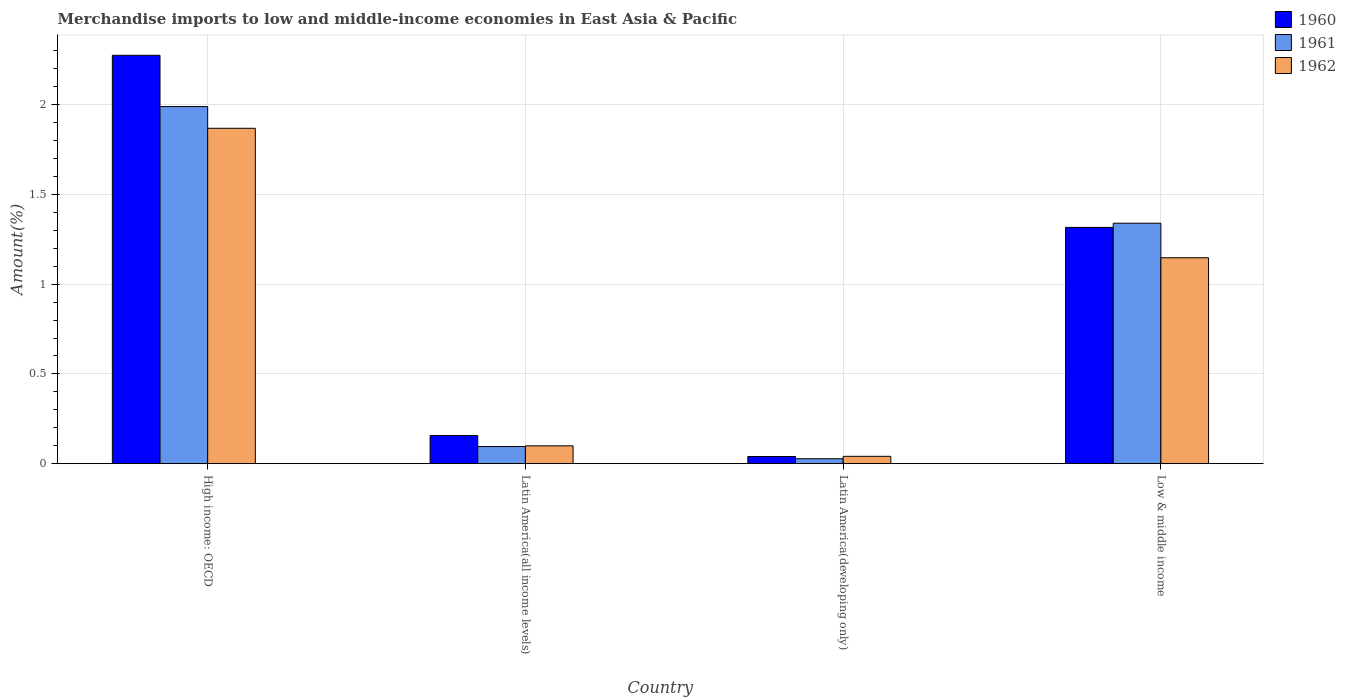Are the number of bars per tick equal to the number of legend labels?
Give a very brief answer. Yes. How many bars are there on the 4th tick from the left?
Your answer should be compact. 3. What is the label of the 3rd group of bars from the left?
Provide a succinct answer. Latin America(developing only). In how many cases, is the number of bars for a given country not equal to the number of legend labels?
Make the answer very short. 0. What is the percentage of amount earned from merchandise imports in 1960 in Low & middle income?
Make the answer very short. 1.32. Across all countries, what is the maximum percentage of amount earned from merchandise imports in 1961?
Provide a short and direct response. 1.99. Across all countries, what is the minimum percentage of amount earned from merchandise imports in 1962?
Provide a short and direct response. 0.04. In which country was the percentage of amount earned from merchandise imports in 1962 maximum?
Your answer should be very brief. High income: OECD. In which country was the percentage of amount earned from merchandise imports in 1961 minimum?
Provide a succinct answer. Latin America(developing only). What is the total percentage of amount earned from merchandise imports in 1961 in the graph?
Provide a short and direct response. 3.45. What is the difference between the percentage of amount earned from merchandise imports in 1962 in High income: OECD and that in Low & middle income?
Your response must be concise. 0.72. What is the difference between the percentage of amount earned from merchandise imports in 1960 in Latin America(developing only) and the percentage of amount earned from merchandise imports in 1961 in High income: OECD?
Keep it short and to the point. -1.95. What is the average percentage of amount earned from merchandise imports in 1961 per country?
Ensure brevity in your answer.  0.86. What is the difference between the percentage of amount earned from merchandise imports of/in 1961 and percentage of amount earned from merchandise imports of/in 1962 in Low & middle income?
Your response must be concise. 0.19. In how many countries, is the percentage of amount earned from merchandise imports in 1960 greater than 1.2 %?
Your answer should be very brief. 2. What is the ratio of the percentage of amount earned from merchandise imports in 1962 in Latin America(developing only) to that in Low & middle income?
Give a very brief answer. 0.04. Is the percentage of amount earned from merchandise imports in 1961 in High income: OECD less than that in Low & middle income?
Provide a short and direct response. No. Is the difference between the percentage of amount earned from merchandise imports in 1961 in Latin America(all income levels) and Low & middle income greater than the difference between the percentage of amount earned from merchandise imports in 1962 in Latin America(all income levels) and Low & middle income?
Provide a succinct answer. No. What is the difference between the highest and the second highest percentage of amount earned from merchandise imports in 1961?
Your response must be concise. -1.89. What is the difference between the highest and the lowest percentage of amount earned from merchandise imports in 1961?
Make the answer very short. 1.96. In how many countries, is the percentage of amount earned from merchandise imports in 1962 greater than the average percentage of amount earned from merchandise imports in 1962 taken over all countries?
Provide a succinct answer. 2. Is the sum of the percentage of amount earned from merchandise imports in 1961 in Latin America(developing only) and Low & middle income greater than the maximum percentage of amount earned from merchandise imports in 1962 across all countries?
Keep it short and to the point. No. What does the 2nd bar from the right in Latin America(developing only) represents?
Offer a very short reply. 1961. Is it the case that in every country, the sum of the percentage of amount earned from merchandise imports in 1962 and percentage of amount earned from merchandise imports in 1961 is greater than the percentage of amount earned from merchandise imports in 1960?
Keep it short and to the point. Yes. How many countries are there in the graph?
Offer a very short reply. 4. How are the legend labels stacked?
Provide a succinct answer. Vertical. What is the title of the graph?
Your response must be concise. Merchandise imports to low and middle-income economies in East Asia & Pacific. What is the label or title of the X-axis?
Your response must be concise. Country. What is the label or title of the Y-axis?
Provide a short and direct response. Amount(%). What is the Amount(%) in 1960 in High income: OECD?
Give a very brief answer. 2.27. What is the Amount(%) of 1961 in High income: OECD?
Keep it short and to the point. 1.99. What is the Amount(%) of 1962 in High income: OECD?
Make the answer very short. 1.87. What is the Amount(%) of 1960 in Latin America(all income levels)?
Your answer should be very brief. 0.16. What is the Amount(%) in 1961 in Latin America(all income levels)?
Your response must be concise. 0.1. What is the Amount(%) of 1962 in Latin America(all income levels)?
Ensure brevity in your answer.  0.1. What is the Amount(%) of 1960 in Latin America(developing only)?
Make the answer very short. 0.04. What is the Amount(%) of 1961 in Latin America(developing only)?
Your response must be concise. 0.03. What is the Amount(%) in 1962 in Latin America(developing only)?
Provide a short and direct response. 0.04. What is the Amount(%) of 1960 in Low & middle income?
Keep it short and to the point. 1.32. What is the Amount(%) of 1961 in Low & middle income?
Your answer should be very brief. 1.34. What is the Amount(%) in 1962 in Low & middle income?
Ensure brevity in your answer.  1.15. Across all countries, what is the maximum Amount(%) in 1960?
Give a very brief answer. 2.27. Across all countries, what is the maximum Amount(%) in 1961?
Provide a succinct answer. 1.99. Across all countries, what is the maximum Amount(%) in 1962?
Keep it short and to the point. 1.87. Across all countries, what is the minimum Amount(%) of 1960?
Make the answer very short. 0.04. Across all countries, what is the minimum Amount(%) of 1961?
Provide a short and direct response. 0.03. Across all countries, what is the minimum Amount(%) in 1962?
Give a very brief answer. 0.04. What is the total Amount(%) in 1960 in the graph?
Keep it short and to the point. 3.79. What is the total Amount(%) of 1961 in the graph?
Keep it short and to the point. 3.45. What is the total Amount(%) in 1962 in the graph?
Offer a very short reply. 3.16. What is the difference between the Amount(%) of 1960 in High income: OECD and that in Latin America(all income levels)?
Make the answer very short. 2.12. What is the difference between the Amount(%) of 1961 in High income: OECD and that in Latin America(all income levels)?
Your answer should be very brief. 1.89. What is the difference between the Amount(%) of 1962 in High income: OECD and that in Latin America(all income levels)?
Give a very brief answer. 1.77. What is the difference between the Amount(%) of 1960 in High income: OECD and that in Latin America(developing only)?
Your response must be concise. 2.23. What is the difference between the Amount(%) in 1961 in High income: OECD and that in Latin America(developing only)?
Keep it short and to the point. 1.96. What is the difference between the Amount(%) of 1962 in High income: OECD and that in Latin America(developing only)?
Your response must be concise. 1.83. What is the difference between the Amount(%) in 1960 in High income: OECD and that in Low & middle income?
Provide a short and direct response. 0.96. What is the difference between the Amount(%) of 1961 in High income: OECD and that in Low & middle income?
Your response must be concise. 0.65. What is the difference between the Amount(%) of 1962 in High income: OECD and that in Low & middle income?
Your response must be concise. 0.72. What is the difference between the Amount(%) in 1960 in Latin America(all income levels) and that in Latin America(developing only)?
Make the answer very short. 0.12. What is the difference between the Amount(%) of 1961 in Latin America(all income levels) and that in Latin America(developing only)?
Provide a short and direct response. 0.07. What is the difference between the Amount(%) in 1962 in Latin America(all income levels) and that in Latin America(developing only)?
Make the answer very short. 0.06. What is the difference between the Amount(%) of 1960 in Latin America(all income levels) and that in Low & middle income?
Offer a very short reply. -1.16. What is the difference between the Amount(%) in 1961 in Latin America(all income levels) and that in Low & middle income?
Provide a succinct answer. -1.24. What is the difference between the Amount(%) of 1962 in Latin America(all income levels) and that in Low & middle income?
Keep it short and to the point. -1.05. What is the difference between the Amount(%) in 1960 in Latin America(developing only) and that in Low & middle income?
Offer a terse response. -1.28. What is the difference between the Amount(%) in 1961 in Latin America(developing only) and that in Low & middle income?
Offer a terse response. -1.31. What is the difference between the Amount(%) of 1962 in Latin America(developing only) and that in Low & middle income?
Ensure brevity in your answer.  -1.11. What is the difference between the Amount(%) in 1960 in High income: OECD and the Amount(%) in 1961 in Latin America(all income levels)?
Ensure brevity in your answer.  2.18. What is the difference between the Amount(%) in 1960 in High income: OECD and the Amount(%) in 1962 in Latin America(all income levels)?
Give a very brief answer. 2.17. What is the difference between the Amount(%) in 1961 in High income: OECD and the Amount(%) in 1962 in Latin America(all income levels)?
Your response must be concise. 1.89. What is the difference between the Amount(%) in 1960 in High income: OECD and the Amount(%) in 1961 in Latin America(developing only)?
Your answer should be very brief. 2.25. What is the difference between the Amount(%) in 1960 in High income: OECD and the Amount(%) in 1962 in Latin America(developing only)?
Make the answer very short. 2.23. What is the difference between the Amount(%) of 1961 in High income: OECD and the Amount(%) of 1962 in Latin America(developing only)?
Ensure brevity in your answer.  1.95. What is the difference between the Amount(%) of 1960 in High income: OECD and the Amount(%) of 1961 in Low & middle income?
Offer a terse response. 0.93. What is the difference between the Amount(%) in 1960 in High income: OECD and the Amount(%) in 1962 in Low & middle income?
Your answer should be very brief. 1.13. What is the difference between the Amount(%) in 1961 in High income: OECD and the Amount(%) in 1962 in Low & middle income?
Ensure brevity in your answer.  0.84. What is the difference between the Amount(%) of 1960 in Latin America(all income levels) and the Amount(%) of 1961 in Latin America(developing only)?
Provide a short and direct response. 0.13. What is the difference between the Amount(%) in 1960 in Latin America(all income levels) and the Amount(%) in 1962 in Latin America(developing only)?
Provide a succinct answer. 0.12. What is the difference between the Amount(%) of 1961 in Latin America(all income levels) and the Amount(%) of 1962 in Latin America(developing only)?
Offer a very short reply. 0.05. What is the difference between the Amount(%) in 1960 in Latin America(all income levels) and the Amount(%) in 1961 in Low & middle income?
Provide a succinct answer. -1.18. What is the difference between the Amount(%) of 1960 in Latin America(all income levels) and the Amount(%) of 1962 in Low & middle income?
Give a very brief answer. -0.99. What is the difference between the Amount(%) in 1961 in Latin America(all income levels) and the Amount(%) in 1962 in Low & middle income?
Make the answer very short. -1.05. What is the difference between the Amount(%) in 1960 in Latin America(developing only) and the Amount(%) in 1961 in Low & middle income?
Provide a short and direct response. -1.3. What is the difference between the Amount(%) in 1960 in Latin America(developing only) and the Amount(%) in 1962 in Low & middle income?
Make the answer very short. -1.11. What is the difference between the Amount(%) of 1961 in Latin America(developing only) and the Amount(%) of 1962 in Low & middle income?
Provide a succinct answer. -1.12. What is the average Amount(%) of 1960 per country?
Make the answer very short. 0.95. What is the average Amount(%) in 1961 per country?
Your answer should be compact. 0.86. What is the average Amount(%) of 1962 per country?
Give a very brief answer. 0.79. What is the difference between the Amount(%) in 1960 and Amount(%) in 1961 in High income: OECD?
Offer a very short reply. 0.29. What is the difference between the Amount(%) of 1960 and Amount(%) of 1962 in High income: OECD?
Make the answer very short. 0.41. What is the difference between the Amount(%) of 1961 and Amount(%) of 1962 in High income: OECD?
Provide a short and direct response. 0.12. What is the difference between the Amount(%) of 1960 and Amount(%) of 1961 in Latin America(all income levels)?
Your answer should be compact. 0.06. What is the difference between the Amount(%) in 1960 and Amount(%) in 1962 in Latin America(all income levels)?
Offer a terse response. 0.06. What is the difference between the Amount(%) of 1961 and Amount(%) of 1962 in Latin America(all income levels)?
Your answer should be compact. -0. What is the difference between the Amount(%) in 1960 and Amount(%) in 1961 in Latin America(developing only)?
Provide a succinct answer. 0.01. What is the difference between the Amount(%) in 1960 and Amount(%) in 1962 in Latin America(developing only)?
Offer a terse response. -0. What is the difference between the Amount(%) in 1961 and Amount(%) in 1962 in Latin America(developing only)?
Provide a short and direct response. -0.01. What is the difference between the Amount(%) in 1960 and Amount(%) in 1961 in Low & middle income?
Your answer should be compact. -0.02. What is the difference between the Amount(%) of 1960 and Amount(%) of 1962 in Low & middle income?
Keep it short and to the point. 0.17. What is the difference between the Amount(%) of 1961 and Amount(%) of 1962 in Low & middle income?
Provide a succinct answer. 0.19. What is the ratio of the Amount(%) in 1960 in High income: OECD to that in Latin America(all income levels)?
Ensure brevity in your answer.  14.49. What is the ratio of the Amount(%) in 1961 in High income: OECD to that in Latin America(all income levels)?
Keep it short and to the point. 20.76. What is the ratio of the Amount(%) in 1962 in High income: OECD to that in Latin America(all income levels)?
Keep it short and to the point. 18.75. What is the ratio of the Amount(%) of 1960 in High income: OECD to that in Latin America(developing only)?
Your answer should be very brief. 56.7. What is the ratio of the Amount(%) in 1961 in High income: OECD to that in Latin America(developing only)?
Your answer should be very brief. 71.56. What is the ratio of the Amount(%) in 1962 in High income: OECD to that in Latin America(developing only)?
Your answer should be compact. 45.19. What is the ratio of the Amount(%) in 1960 in High income: OECD to that in Low & middle income?
Offer a terse response. 1.73. What is the ratio of the Amount(%) of 1961 in High income: OECD to that in Low & middle income?
Provide a short and direct response. 1.48. What is the ratio of the Amount(%) of 1962 in High income: OECD to that in Low & middle income?
Ensure brevity in your answer.  1.63. What is the ratio of the Amount(%) of 1960 in Latin America(all income levels) to that in Latin America(developing only)?
Give a very brief answer. 3.91. What is the ratio of the Amount(%) of 1961 in Latin America(all income levels) to that in Latin America(developing only)?
Your response must be concise. 3.45. What is the ratio of the Amount(%) in 1962 in Latin America(all income levels) to that in Latin America(developing only)?
Your answer should be very brief. 2.41. What is the ratio of the Amount(%) in 1960 in Latin America(all income levels) to that in Low & middle income?
Ensure brevity in your answer.  0.12. What is the ratio of the Amount(%) of 1961 in Latin America(all income levels) to that in Low & middle income?
Your answer should be very brief. 0.07. What is the ratio of the Amount(%) of 1962 in Latin America(all income levels) to that in Low & middle income?
Offer a very short reply. 0.09. What is the ratio of the Amount(%) of 1960 in Latin America(developing only) to that in Low & middle income?
Keep it short and to the point. 0.03. What is the ratio of the Amount(%) in 1961 in Latin America(developing only) to that in Low & middle income?
Keep it short and to the point. 0.02. What is the ratio of the Amount(%) of 1962 in Latin America(developing only) to that in Low & middle income?
Your answer should be compact. 0.04. What is the difference between the highest and the second highest Amount(%) in 1960?
Provide a short and direct response. 0.96. What is the difference between the highest and the second highest Amount(%) of 1961?
Your answer should be very brief. 0.65. What is the difference between the highest and the second highest Amount(%) of 1962?
Keep it short and to the point. 0.72. What is the difference between the highest and the lowest Amount(%) of 1960?
Offer a terse response. 2.23. What is the difference between the highest and the lowest Amount(%) of 1961?
Keep it short and to the point. 1.96. What is the difference between the highest and the lowest Amount(%) of 1962?
Your answer should be very brief. 1.83. 